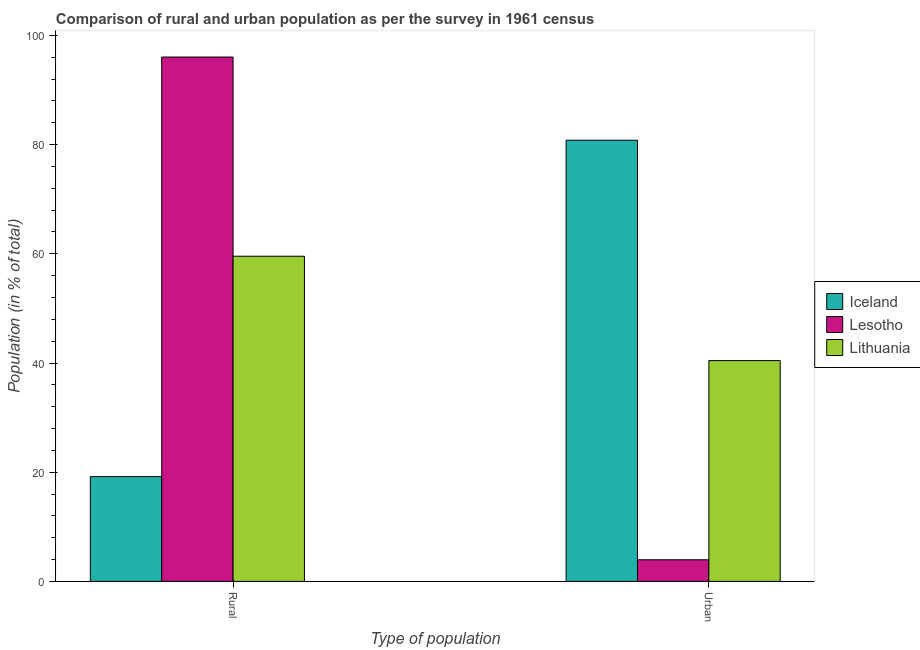How many different coloured bars are there?
Ensure brevity in your answer.  3. How many groups of bars are there?
Make the answer very short. 2. How many bars are there on the 1st tick from the left?
Your answer should be very brief. 3. How many bars are there on the 1st tick from the right?
Give a very brief answer. 3. What is the label of the 2nd group of bars from the left?
Provide a succinct answer. Urban. What is the urban population in Lesotho?
Offer a very short reply. 3.96. Across all countries, what is the maximum rural population?
Make the answer very short. 96.04. Across all countries, what is the minimum rural population?
Ensure brevity in your answer.  19.2. In which country was the urban population minimum?
Ensure brevity in your answer.  Lesotho. What is the total urban population in the graph?
Keep it short and to the point. 125.21. What is the difference between the rural population in Lesotho and that in Iceland?
Your answer should be very brief. 76.84. What is the difference between the rural population in Lesotho and the urban population in Iceland?
Provide a short and direct response. 15.24. What is the average rural population per country?
Offer a terse response. 58.26. What is the difference between the rural population and urban population in Lithuania?
Ensure brevity in your answer.  19.11. In how many countries, is the urban population greater than 32 %?
Your answer should be very brief. 2. What is the ratio of the rural population in Lesotho to that in Iceland?
Provide a short and direct response. 5. Is the urban population in Lithuania less than that in Iceland?
Give a very brief answer. Yes. What does the 2nd bar from the left in Urban represents?
Keep it short and to the point. Lesotho. How many countries are there in the graph?
Offer a terse response. 3. Are the values on the major ticks of Y-axis written in scientific E-notation?
Your answer should be very brief. No. Where does the legend appear in the graph?
Your response must be concise. Center right. How many legend labels are there?
Provide a succinct answer. 3. How are the legend labels stacked?
Give a very brief answer. Vertical. What is the title of the graph?
Make the answer very short. Comparison of rural and urban population as per the survey in 1961 census. Does "United States" appear as one of the legend labels in the graph?
Offer a terse response. No. What is the label or title of the X-axis?
Give a very brief answer. Type of population. What is the label or title of the Y-axis?
Your response must be concise. Population (in % of total). What is the Population (in % of total) of Iceland in Rural?
Offer a very short reply. 19.2. What is the Population (in % of total) of Lesotho in Rural?
Your response must be concise. 96.04. What is the Population (in % of total) of Lithuania in Rural?
Make the answer very short. 59.56. What is the Population (in % of total) of Iceland in Urban?
Give a very brief answer. 80.8. What is the Population (in % of total) in Lesotho in Urban?
Your answer should be compact. 3.96. What is the Population (in % of total) of Lithuania in Urban?
Provide a short and direct response. 40.44. Across all Type of population, what is the maximum Population (in % of total) in Iceland?
Ensure brevity in your answer.  80.8. Across all Type of population, what is the maximum Population (in % of total) of Lesotho?
Your response must be concise. 96.04. Across all Type of population, what is the maximum Population (in % of total) in Lithuania?
Provide a short and direct response. 59.56. Across all Type of population, what is the minimum Population (in % of total) of Iceland?
Ensure brevity in your answer.  19.2. Across all Type of population, what is the minimum Population (in % of total) of Lesotho?
Give a very brief answer. 3.96. Across all Type of population, what is the minimum Population (in % of total) in Lithuania?
Keep it short and to the point. 40.44. What is the total Population (in % of total) of Iceland in the graph?
Your answer should be compact. 100. What is the total Population (in % of total) of Lesotho in the graph?
Your response must be concise. 100. What is the difference between the Population (in % of total) in Iceland in Rural and that in Urban?
Provide a short and direct response. -61.61. What is the difference between the Population (in % of total) of Lesotho in Rural and that in Urban?
Provide a succinct answer. 92.08. What is the difference between the Population (in % of total) of Lithuania in Rural and that in Urban?
Your answer should be compact. 19.11. What is the difference between the Population (in % of total) of Iceland in Rural and the Population (in % of total) of Lesotho in Urban?
Your answer should be very brief. 15.24. What is the difference between the Population (in % of total) in Iceland in Rural and the Population (in % of total) in Lithuania in Urban?
Provide a short and direct response. -21.25. What is the difference between the Population (in % of total) in Lesotho in Rural and the Population (in % of total) in Lithuania in Urban?
Keep it short and to the point. 55.6. What is the difference between the Population (in % of total) in Iceland and Population (in % of total) in Lesotho in Rural?
Ensure brevity in your answer.  -76.84. What is the difference between the Population (in % of total) in Iceland and Population (in % of total) in Lithuania in Rural?
Your answer should be compact. -40.36. What is the difference between the Population (in % of total) in Lesotho and Population (in % of total) in Lithuania in Rural?
Your answer should be compact. 36.48. What is the difference between the Population (in % of total) of Iceland and Population (in % of total) of Lesotho in Urban?
Ensure brevity in your answer.  76.84. What is the difference between the Population (in % of total) in Iceland and Population (in % of total) in Lithuania in Urban?
Provide a succinct answer. 40.36. What is the difference between the Population (in % of total) in Lesotho and Population (in % of total) in Lithuania in Urban?
Give a very brief answer. -36.48. What is the ratio of the Population (in % of total) in Iceland in Rural to that in Urban?
Provide a short and direct response. 0.24. What is the ratio of the Population (in % of total) in Lesotho in Rural to that in Urban?
Make the answer very short. 24.25. What is the ratio of the Population (in % of total) in Lithuania in Rural to that in Urban?
Offer a terse response. 1.47. What is the difference between the highest and the second highest Population (in % of total) of Iceland?
Give a very brief answer. 61.61. What is the difference between the highest and the second highest Population (in % of total) in Lesotho?
Give a very brief answer. 92.08. What is the difference between the highest and the second highest Population (in % of total) in Lithuania?
Give a very brief answer. 19.11. What is the difference between the highest and the lowest Population (in % of total) of Iceland?
Your response must be concise. 61.61. What is the difference between the highest and the lowest Population (in % of total) in Lesotho?
Give a very brief answer. 92.08. What is the difference between the highest and the lowest Population (in % of total) of Lithuania?
Give a very brief answer. 19.11. 